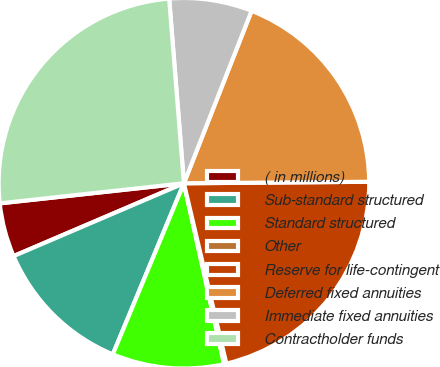<chart> <loc_0><loc_0><loc_500><loc_500><pie_chart><fcel>( in millions)<fcel>Sub-standard structured<fcel>Standard structured<fcel>Other<fcel>Reserve for life-contingent<fcel>Deferred fixed annuities<fcel>Immediate fixed annuities<fcel>Contractholder funds<nl><fcel>4.7%<fcel>12.3%<fcel>9.75%<fcel>0.2%<fcel>21.45%<fcel>18.92%<fcel>7.22%<fcel>25.46%<nl></chart> 